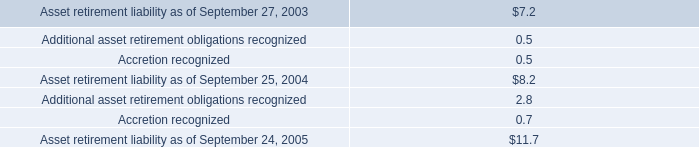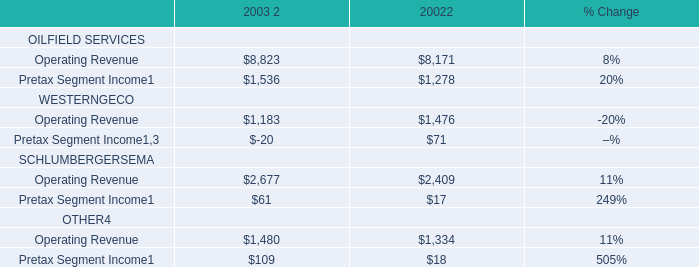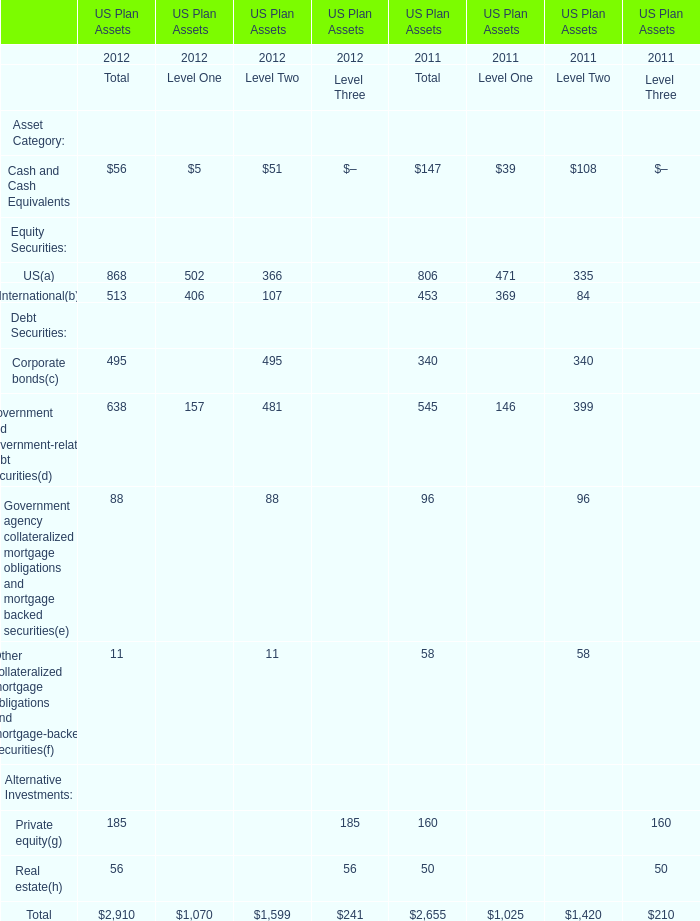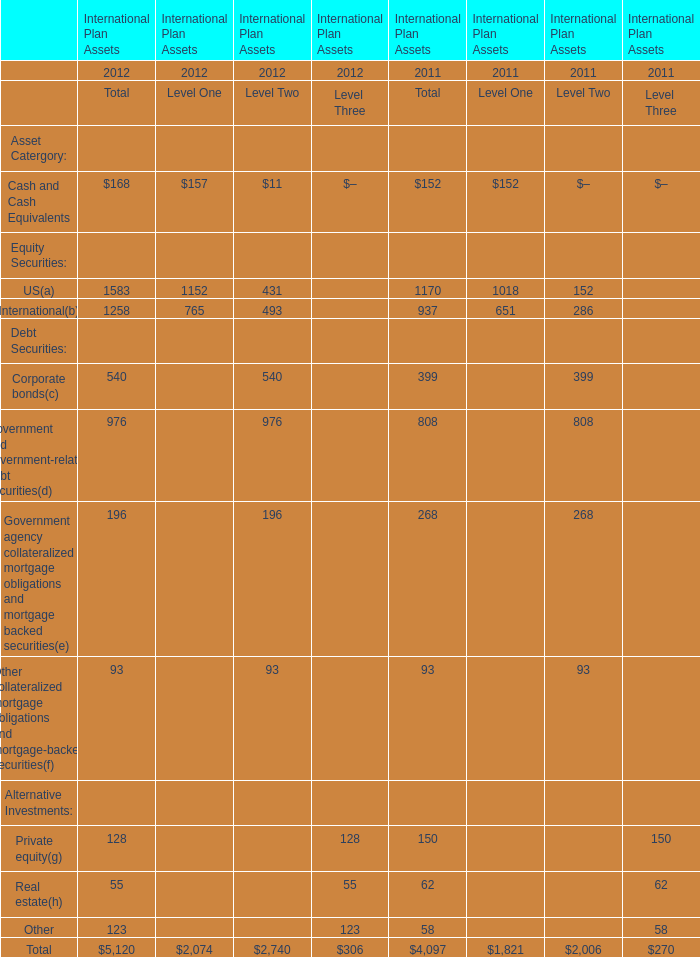What is the sum of Government and government-related debt securities(d), Government agency collateralized mortgage obligations and mortgage backed securities(e) and Other collateralized mortgage obligations and mortgage-backed securities in 2012? 
Computations: ((976 + 196) + 93)
Answer: 1265.0. 